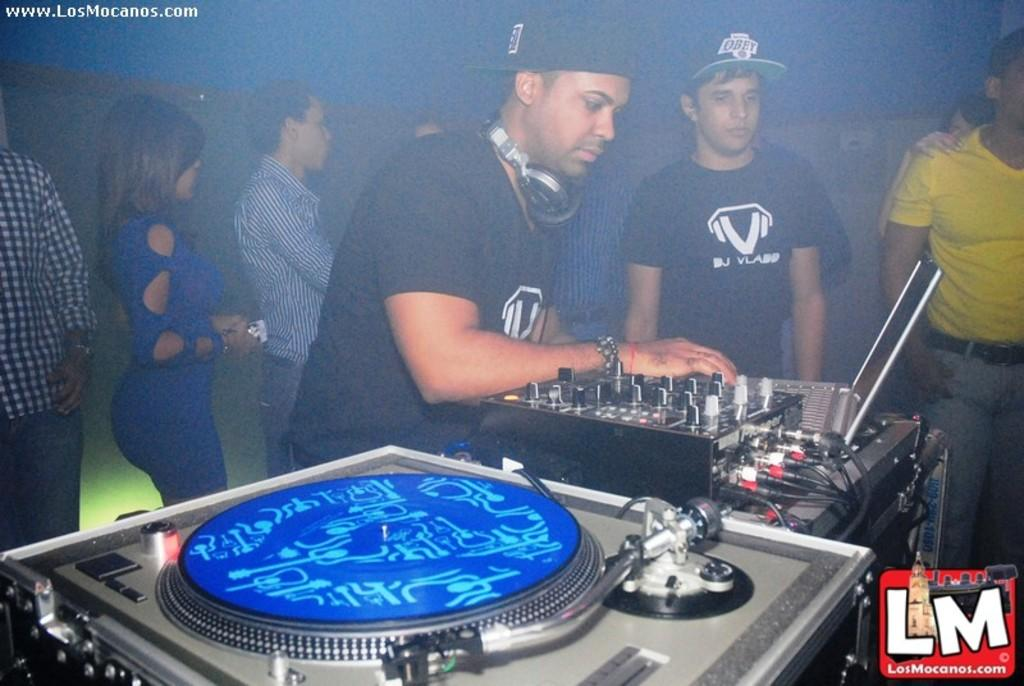What is the main subject of the image? There is a man standing in the center of the image. What is the man doing in the image? The man is playing a DJ. Can you describe the background of the image? There are people in the background of the image, and there is a light visible. What type of lace is being used to wash the throat of the DJ in the image? There is no lace or throat-washing activity depicted in the image; the man is simply playing a DJ. 